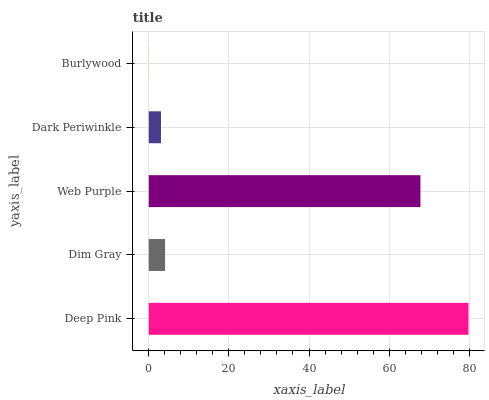Is Burlywood the minimum?
Answer yes or no. Yes. Is Deep Pink the maximum?
Answer yes or no. Yes. Is Dim Gray the minimum?
Answer yes or no. No. Is Dim Gray the maximum?
Answer yes or no. No. Is Deep Pink greater than Dim Gray?
Answer yes or no. Yes. Is Dim Gray less than Deep Pink?
Answer yes or no. Yes. Is Dim Gray greater than Deep Pink?
Answer yes or no. No. Is Deep Pink less than Dim Gray?
Answer yes or no. No. Is Dim Gray the high median?
Answer yes or no. Yes. Is Dim Gray the low median?
Answer yes or no. Yes. Is Web Purple the high median?
Answer yes or no. No. Is Dark Periwinkle the low median?
Answer yes or no. No. 